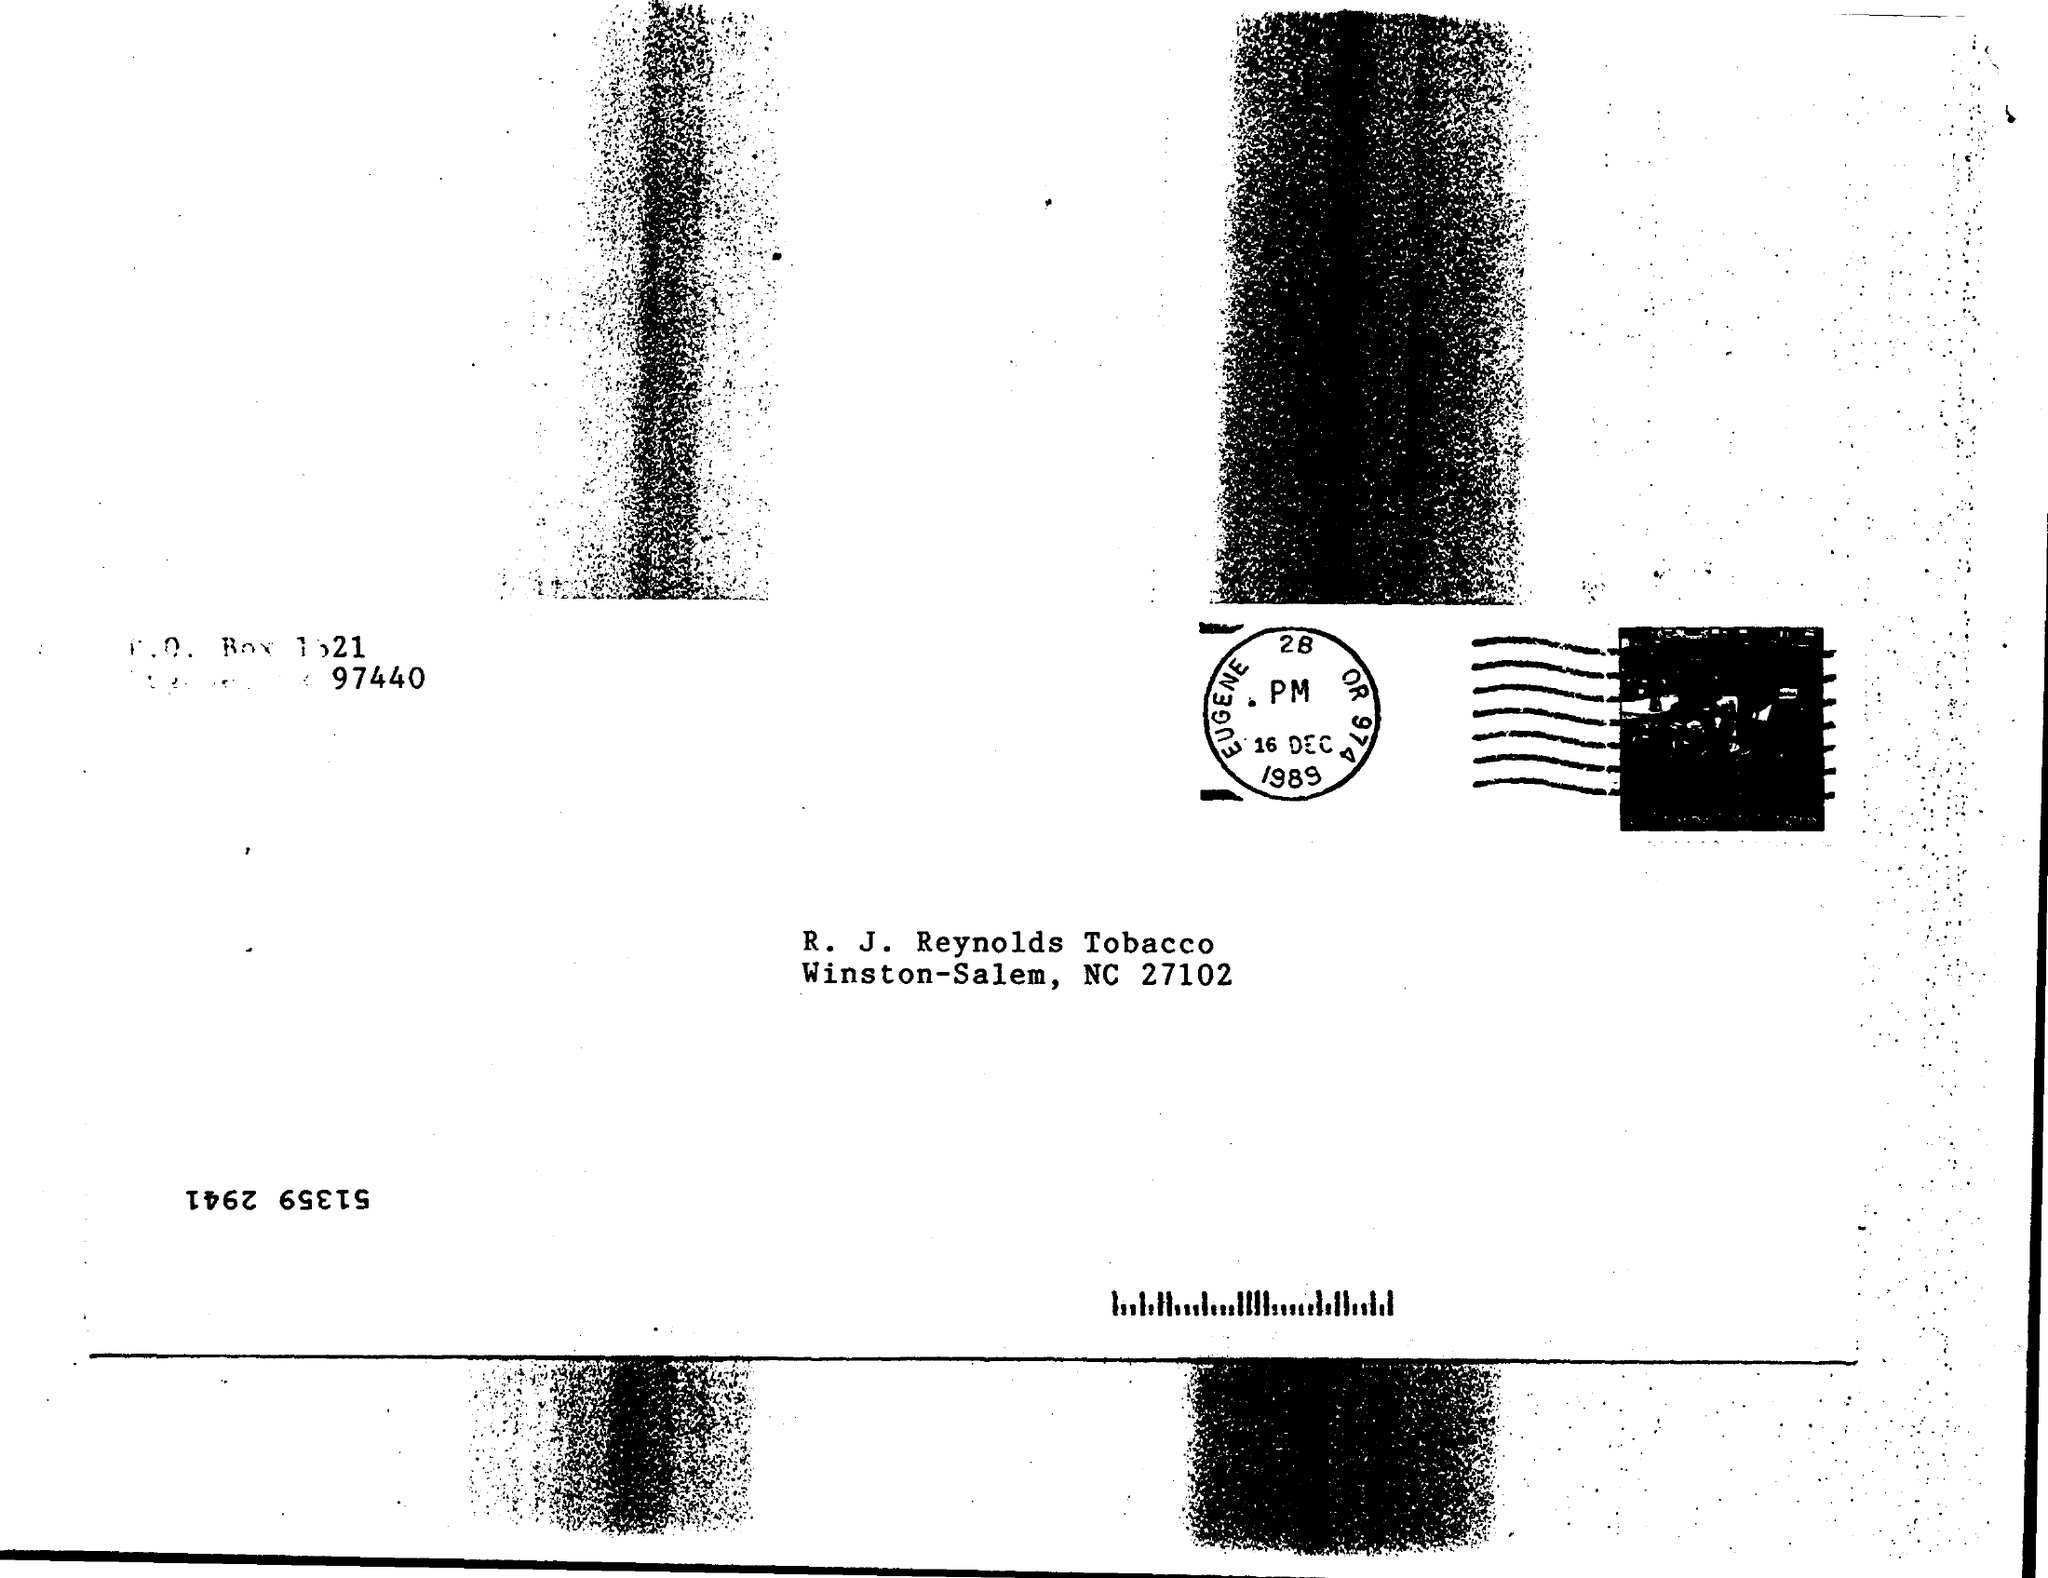Draw attention to some important aspects in this diagram. The date on the stamp is 16 December 1989. 